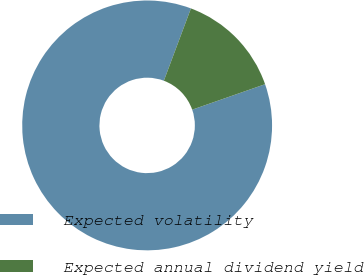Convert chart to OTSL. <chart><loc_0><loc_0><loc_500><loc_500><pie_chart><fcel>Expected volatility<fcel>Expected annual dividend yield<nl><fcel>86.05%<fcel>13.95%<nl></chart> 